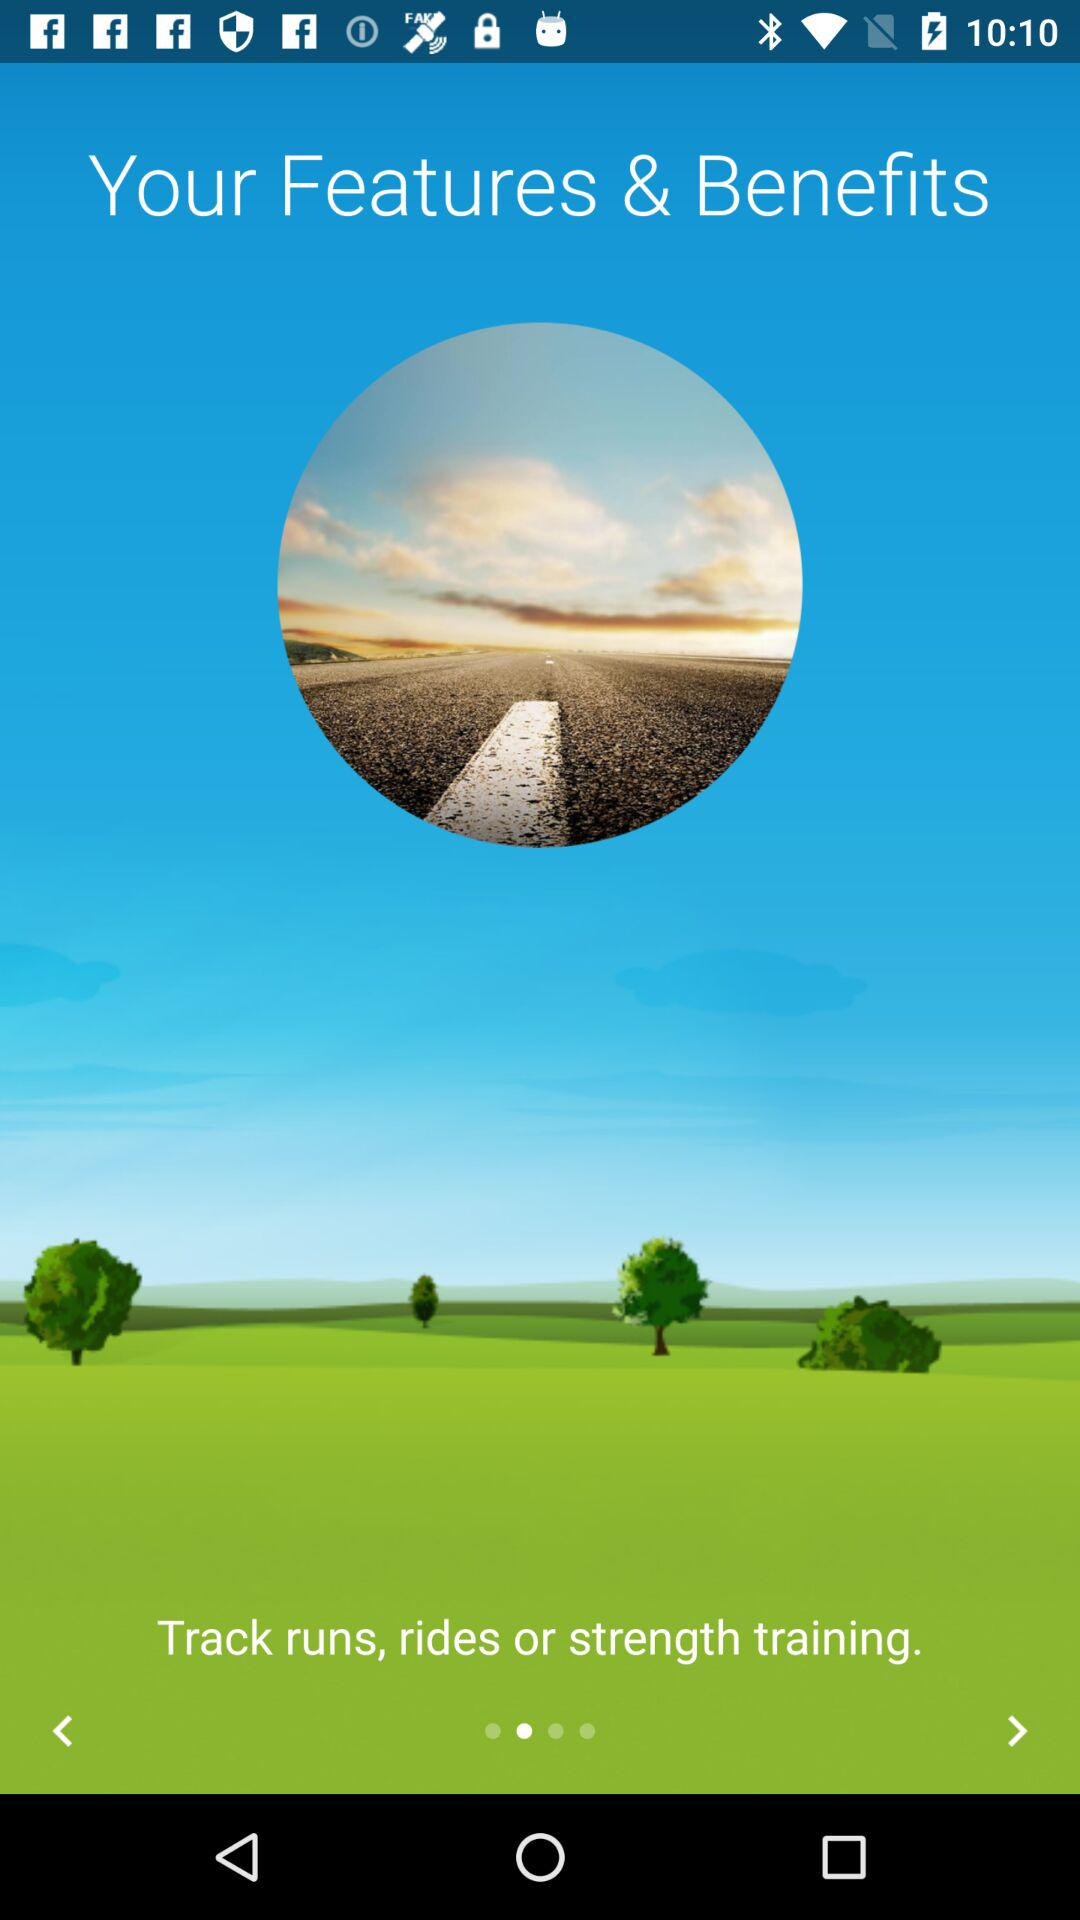If the page number is 1, what will the page number be when the user swipes forward?
Answer the question using a single word or phrase. 2 